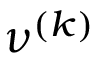Convert formula to latex. <formula><loc_0><loc_0><loc_500><loc_500>\nu ^ { ( k ) }</formula> 